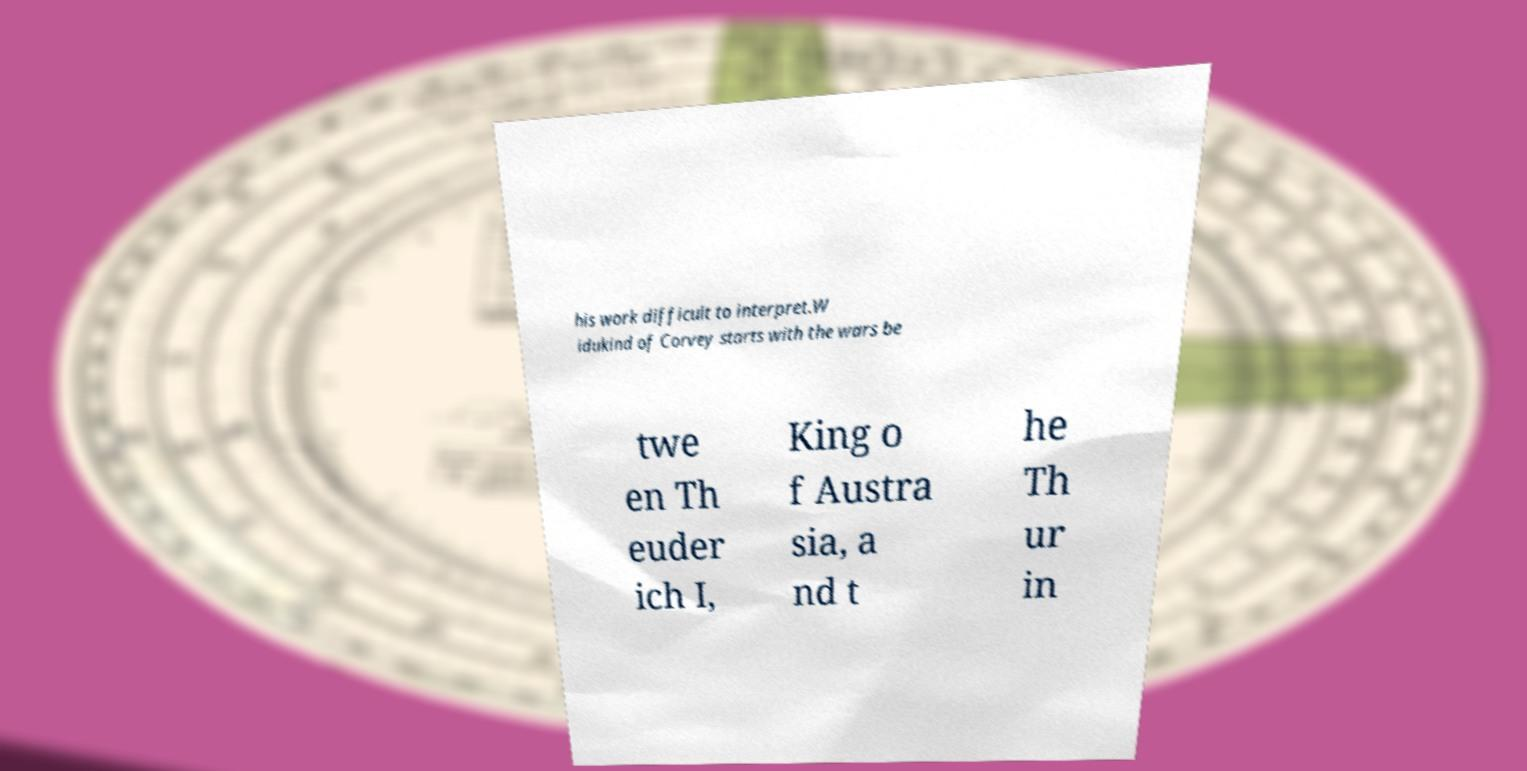I need the written content from this picture converted into text. Can you do that? his work difficult to interpret.W idukind of Corvey starts with the wars be twe en Th euder ich I, King o f Austra sia, a nd t he Th ur in 